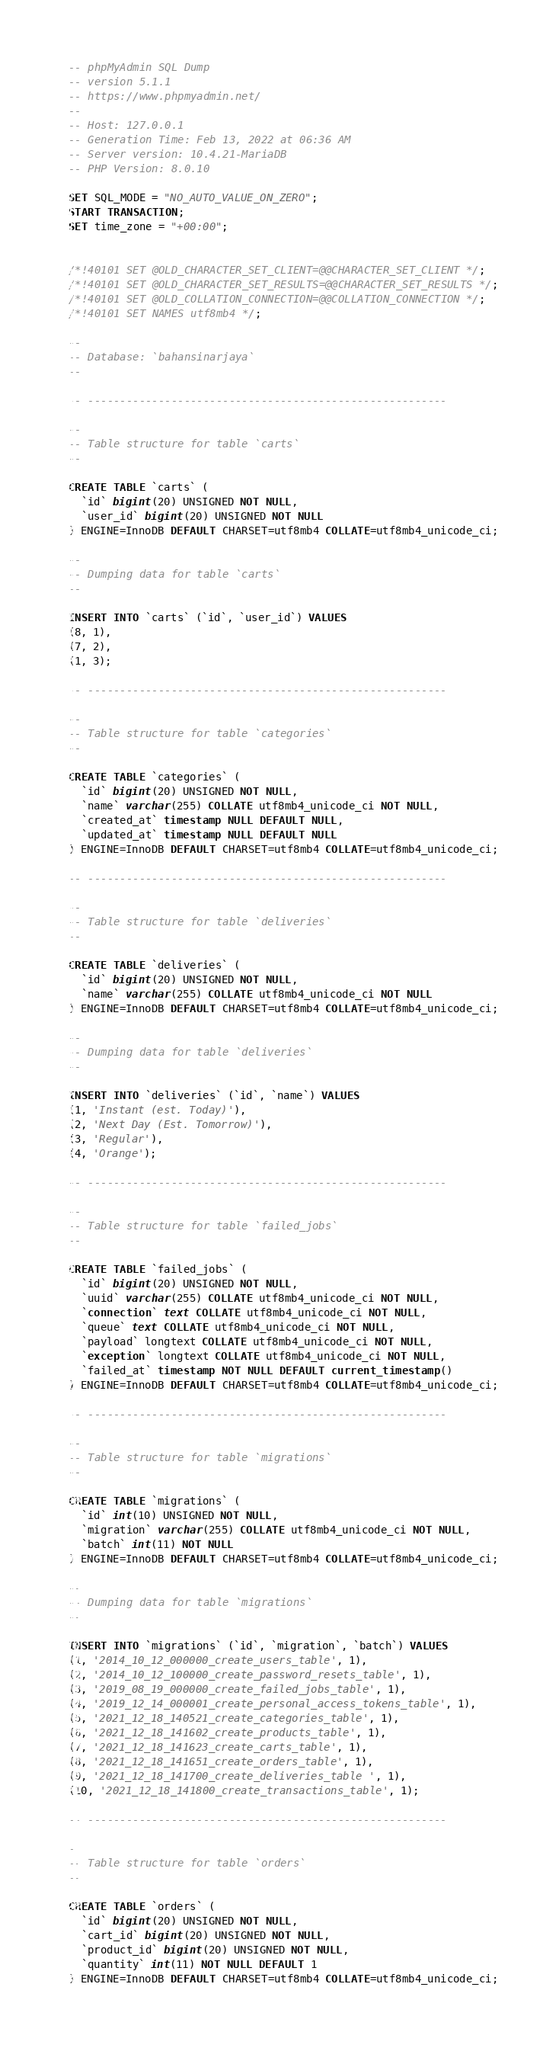Convert code to text. <code><loc_0><loc_0><loc_500><loc_500><_SQL_>-- phpMyAdmin SQL Dump
-- version 5.1.1
-- https://www.phpmyadmin.net/
--
-- Host: 127.0.0.1
-- Generation Time: Feb 13, 2022 at 06:36 AM
-- Server version: 10.4.21-MariaDB
-- PHP Version: 8.0.10

SET SQL_MODE = "NO_AUTO_VALUE_ON_ZERO";
START TRANSACTION;
SET time_zone = "+00:00";


/*!40101 SET @OLD_CHARACTER_SET_CLIENT=@@CHARACTER_SET_CLIENT */;
/*!40101 SET @OLD_CHARACTER_SET_RESULTS=@@CHARACTER_SET_RESULTS */;
/*!40101 SET @OLD_COLLATION_CONNECTION=@@COLLATION_CONNECTION */;
/*!40101 SET NAMES utf8mb4 */;

--
-- Database: `bahansinarjaya`
--

-- --------------------------------------------------------

--
-- Table structure for table `carts`
--

CREATE TABLE `carts` (
  `id` bigint(20) UNSIGNED NOT NULL,
  `user_id` bigint(20) UNSIGNED NOT NULL
) ENGINE=InnoDB DEFAULT CHARSET=utf8mb4 COLLATE=utf8mb4_unicode_ci;

--
-- Dumping data for table `carts`
--

INSERT INTO `carts` (`id`, `user_id`) VALUES
(8, 1),
(7, 2),
(1, 3);

-- --------------------------------------------------------

--
-- Table structure for table `categories`
--

CREATE TABLE `categories` (
  `id` bigint(20) UNSIGNED NOT NULL,
  `name` varchar(255) COLLATE utf8mb4_unicode_ci NOT NULL,
  `created_at` timestamp NULL DEFAULT NULL,
  `updated_at` timestamp NULL DEFAULT NULL
) ENGINE=InnoDB DEFAULT CHARSET=utf8mb4 COLLATE=utf8mb4_unicode_ci;

-- --------------------------------------------------------

--
-- Table structure for table `deliveries`
--

CREATE TABLE `deliveries` (
  `id` bigint(20) UNSIGNED NOT NULL,
  `name` varchar(255) COLLATE utf8mb4_unicode_ci NOT NULL
) ENGINE=InnoDB DEFAULT CHARSET=utf8mb4 COLLATE=utf8mb4_unicode_ci;

--
-- Dumping data for table `deliveries`
--

INSERT INTO `deliveries` (`id`, `name`) VALUES
(1, 'Instant (est. Today)'),
(2, 'Next Day (Est. Tomorrow)'),
(3, 'Regular'),
(4, 'Orange');

-- --------------------------------------------------------

--
-- Table structure for table `failed_jobs`
--

CREATE TABLE `failed_jobs` (
  `id` bigint(20) UNSIGNED NOT NULL,
  `uuid` varchar(255) COLLATE utf8mb4_unicode_ci NOT NULL,
  `connection` text COLLATE utf8mb4_unicode_ci NOT NULL,
  `queue` text COLLATE utf8mb4_unicode_ci NOT NULL,
  `payload` longtext COLLATE utf8mb4_unicode_ci NOT NULL,
  `exception` longtext COLLATE utf8mb4_unicode_ci NOT NULL,
  `failed_at` timestamp NOT NULL DEFAULT current_timestamp()
) ENGINE=InnoDB DEFAULT CHARSET=utf8mb4 COLLATE=utf8mb4_unicode_ci;

-- --------------------------------------------------------

--
-- Table structure for table `migrations`
--

CREATE TABLE `migrations` (
  `id` int(10) UNSIGNED NOT NULL,
  `migration` varchar(255) COLLATE utf8mb4_unicode_ci NOT NULL,
  `batch` int(11) NOT NULL
) ENGINE=InnoDB DEFAULT CHARSET=utf8mb4 COLLATE=utf8mb4_unicode_ci;

--
-- Dumping data for table `migrations`
--

INSERT INTO `migrations` (`id`, `migration`, `batch`) VALUES
(1, '2014_10_12_000000_create_users_table', 1),
(2, '2014_10_12_100000_create_password_resets_table', 1),
(3, '2019_08_19_000000_create_failed_jobs_table', 1),
(4, '2019_12_14_000001_create_personal_access_tokens_table', 1),
(5, '2021_12_18_140521_create_categories_table', 1),
(6, '2021_12_18_141602_create_products_table', 1),
(7, '2021_12_18_141623_create_carts_table', 1),
(8, '2021_12_18_141651_create_orders_table', 1),
(9, '2021_12_18_141700_create_deliveries_table ', 1),
(10, '2021_12_18_141800_create_transactions_table', 1);

-- --------------------------------------------------------

--
-- Table structure for table `orders`
--

CREATE TABLE `orders` (
  `id` bigint(20) UNSIGNED NOT NULL,
  `cart_id` bigint(20) UNSIGNED NOT NULL,
  `product_id` bigint(20) UNSIGNED NOT NULL,
  `quantity` int(11) NOT NULL DEFAULT 1
) ENGINE=InnoDB DEFAULT CHARSET=utf8mb4 COLLATE=utf8mb4_unicode_ci;
</code> 